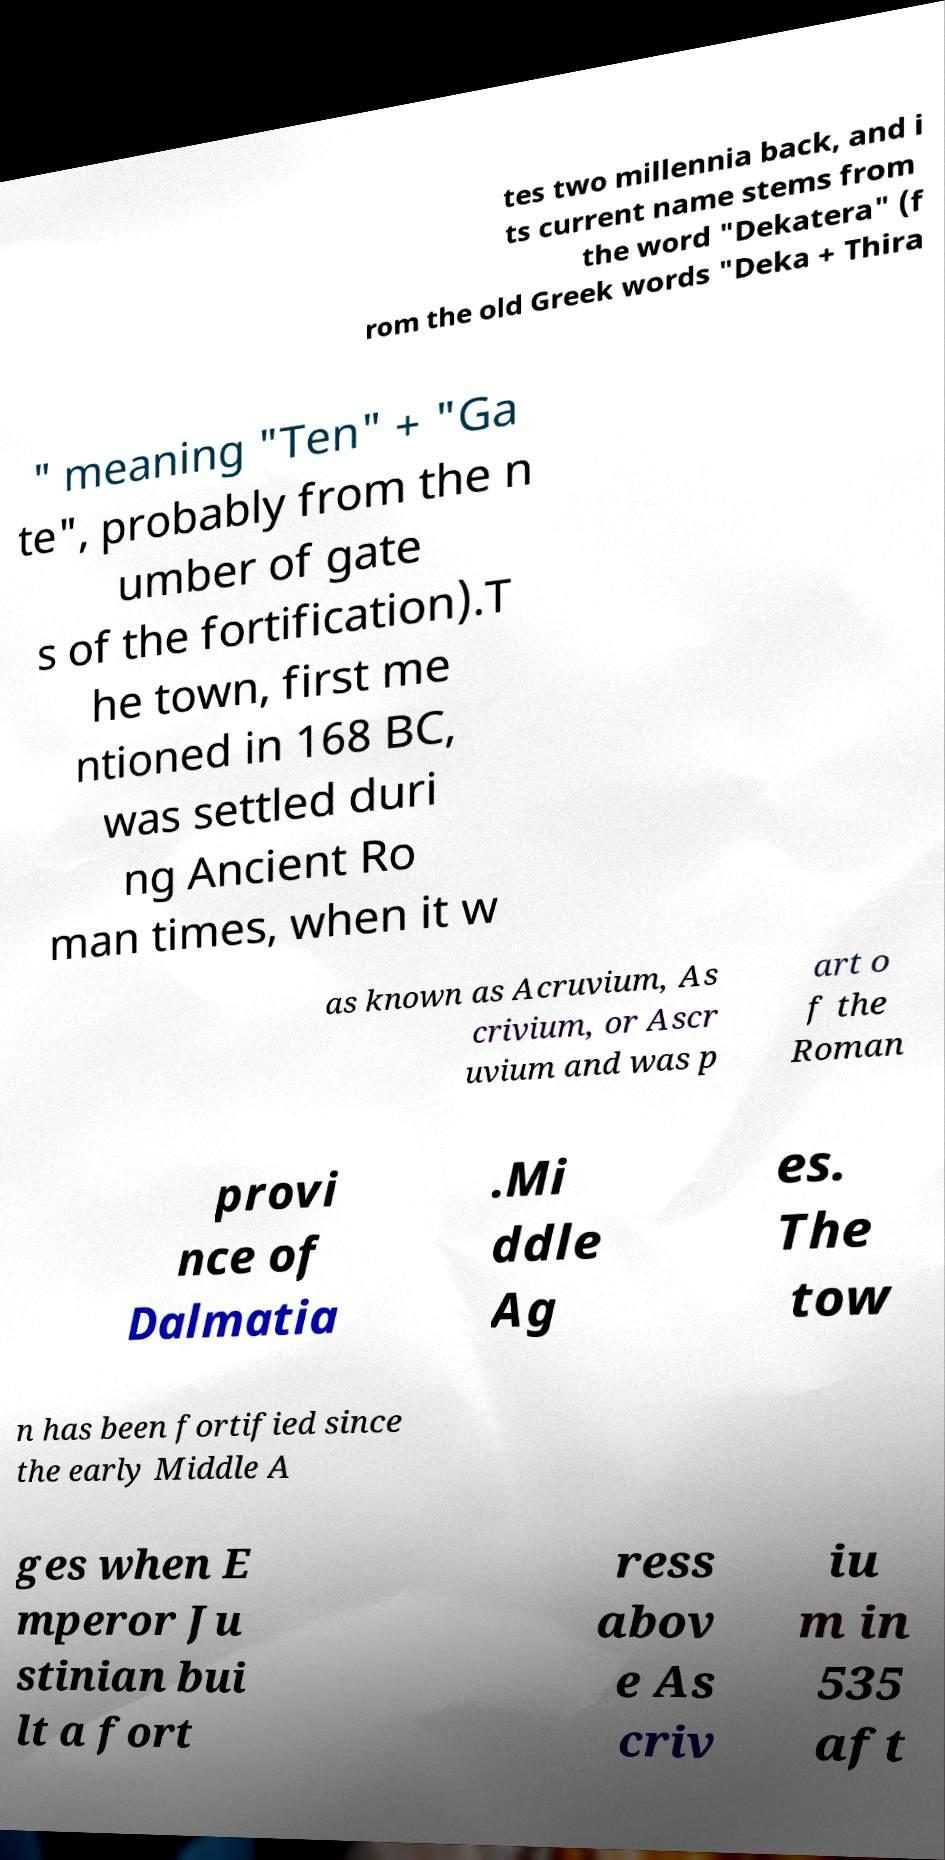I need the written content from this picture converted into text. Can you do that? tes two millennia back, and i ts current name stems from the word "Dekatera" (f rom the old Greek words "Deka + Thira " meaning "Ten" + "Ga te", probably from the n umber of gate s of the fortification).T he town, first me ntioned in 168 BC, was settled duri ng Ancient Ro man times, when it w as known as Acruvium, As crivium, or Ascr uvium and was p art o f the Roman provi nce of Dalmatia .Mi ddle Ag es. The tow n has been fortified since the early Middle A ges when E mperor Ju stinian bui lt a fort ress abov e As criv iu m in 535 aft 